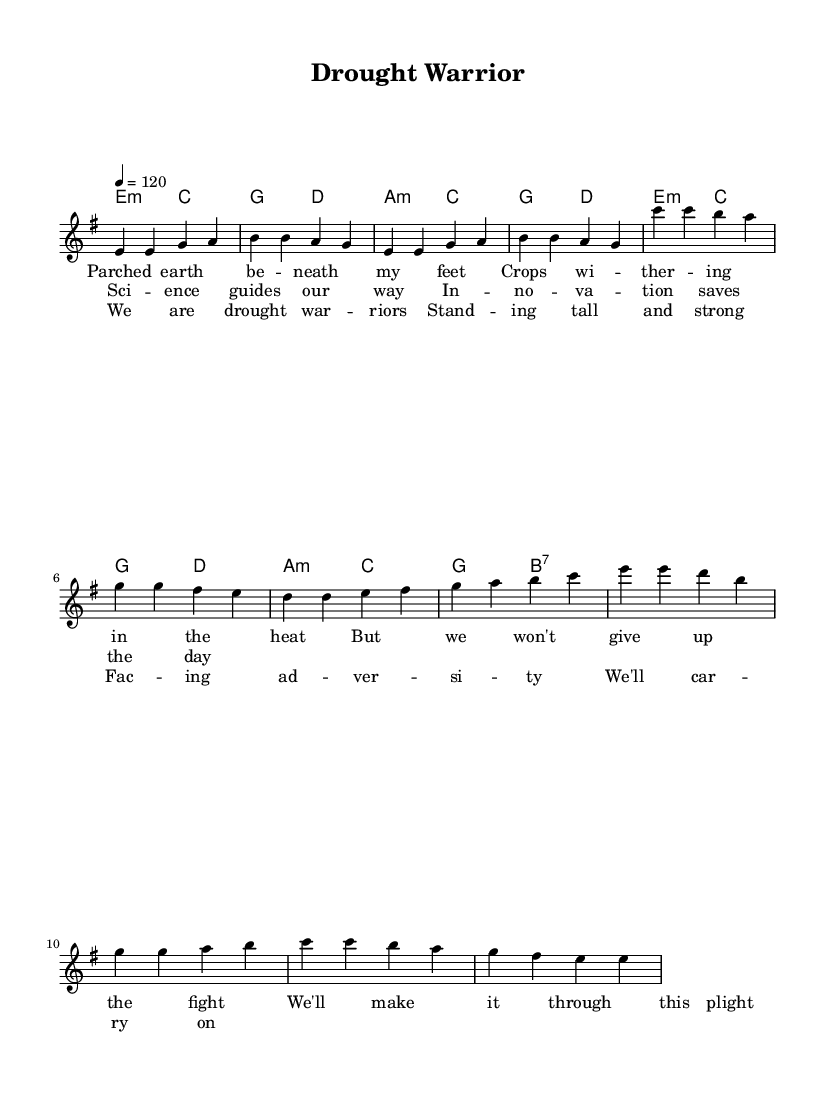What is the key signature of this music? The key signature is E minor, which has one sharp (F#) and indicates that the music will mostly use the notes associated with this key.
Answer: E minor What is the time signature of this music? The time signature is 4/4, meaning there are four beats in each measure and the quarter note gets one beat.
Answer: 4/4 What is the tempo marking of this music? The tempo marking indicates that the music should be played at a speed of 120 beats per minute, which is a moderate tempo.
Answer: 120 What is the predominant musical form used in this piece? The piece has a verse-prechorus-chorus structure, common in rock music, where the verse sets up the story, the pre-chorus builds tension, and the chorus delivers the main message.
Answer: Verse-prechorus-chorus How many measures are in the chorus? The chorus consists of four measures, as indicated by the notation within the score.
Answer: 4 measures Which lyrical theme is expressed in the chorus? The lyrics in the chorus celebrate resilience and strength in the face of adversity, which aligns with the overall theme of the piece.
Answer: Resilience What type of chords are used in the verse section? The verse section primarily uses minor chords (E minor and C major), which evokes a somber tone that reflects the struggles being described in the lyrics.
Answer: Minor chords 